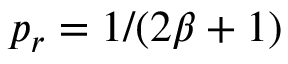<formula> <loc_0><loc_0><loc_500><loc_500>p _ { r } = 1 / ( 2 \beta + 1 )</formula> 